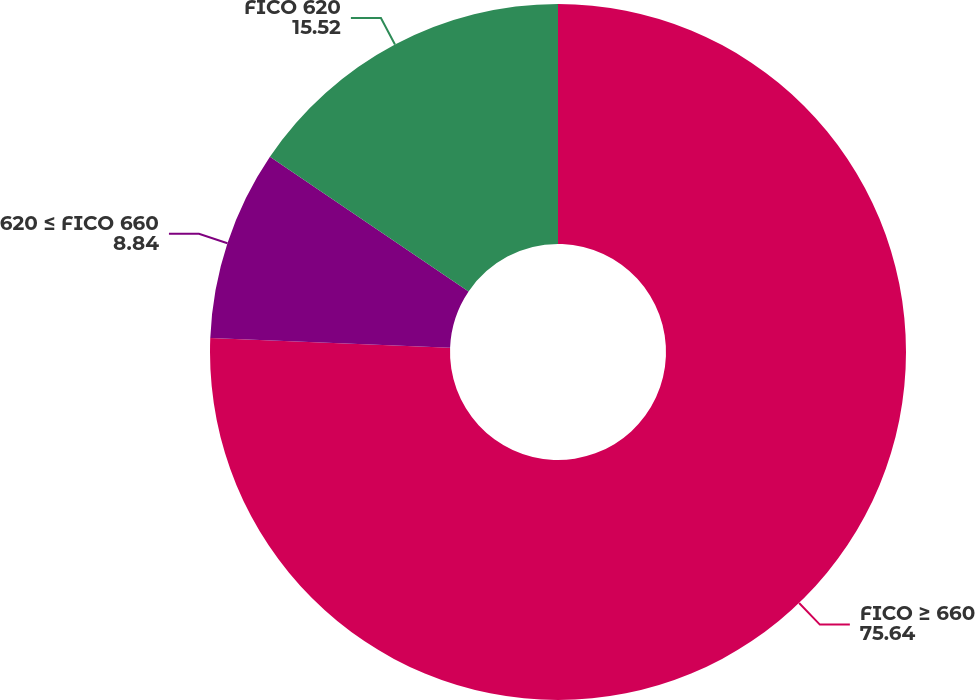<chart> <loc_0><loc_0><loc_500><loc_500><pie_chart><fcel>FICO ≥ 660<fcel>620 ≤ FICO 660<fcel>FICO 620<nl><fcel>75.64%<fcel>8.84%<fcel>15.52%<nl></chart> 